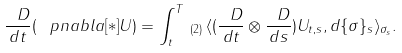<formula> <loc_0><loc_0><loc_500><loc_500>\frac { \ D } { d t } ( \, \ p n a b l a [ * ] U ) = \int _ { t } ^ { T } \, _ { ( 2 ) } \, \langle ( \frac { \ D } { d t } \otimes \frac { \ D } { d s } ) U _ { t , s } , d \{ \sigma \} _ { s } \rangle _ { \sigma _ { s } } .</formula> 